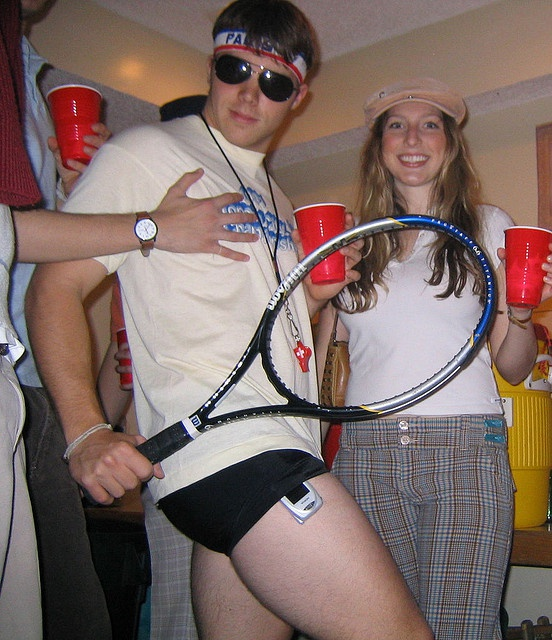Describe the objects in this image and their specific colors. I can see people in black, gray, darkgray, and lightgray tones, people in black, gray, lightgray, and darkgray tones, tennis racket in black, lightgray, darkgray, and gray tones, people in black, gray, darkgray, and maroon tones, and people in black and gray tones in this image. 